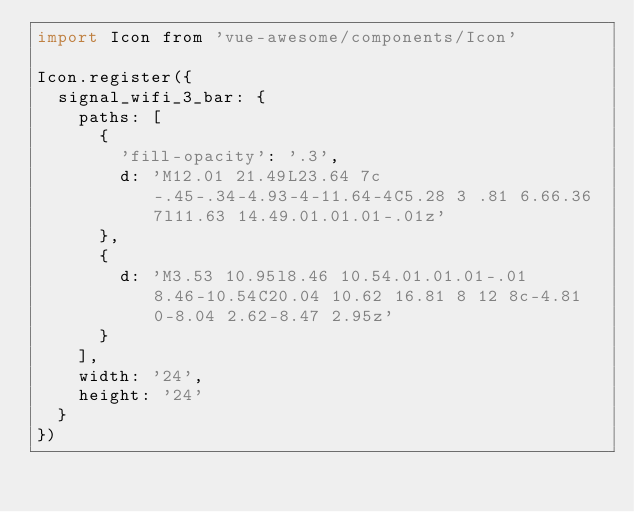<code> <loc_0><loc_0><loc_500><loc_500><_JavaScript_>import Icon from 'vue-awesome/components/Icon'

Icon.register({
  signal_wifi_3_bar: {
    paths: [
      {
        'fill-opacity': '.3',
        d: 'M12.01 21.49L23.64 7c-.45-.34-4.93-4-11.64-4C5.28 3 .81 6.66.36 7l11.63 14.49.01.01.01-.01z'
      },
      {
        d: 'M3.53 10.95l8.46 10.54.01.01.01-.01 8.46-10.54C20.04 10.62 16.81 8 12 8c-4.81 0-8.04 2.62-8.47 2.95z'
      }
    ],
    width: '24',
    height: '24'
  }
})
</code> 